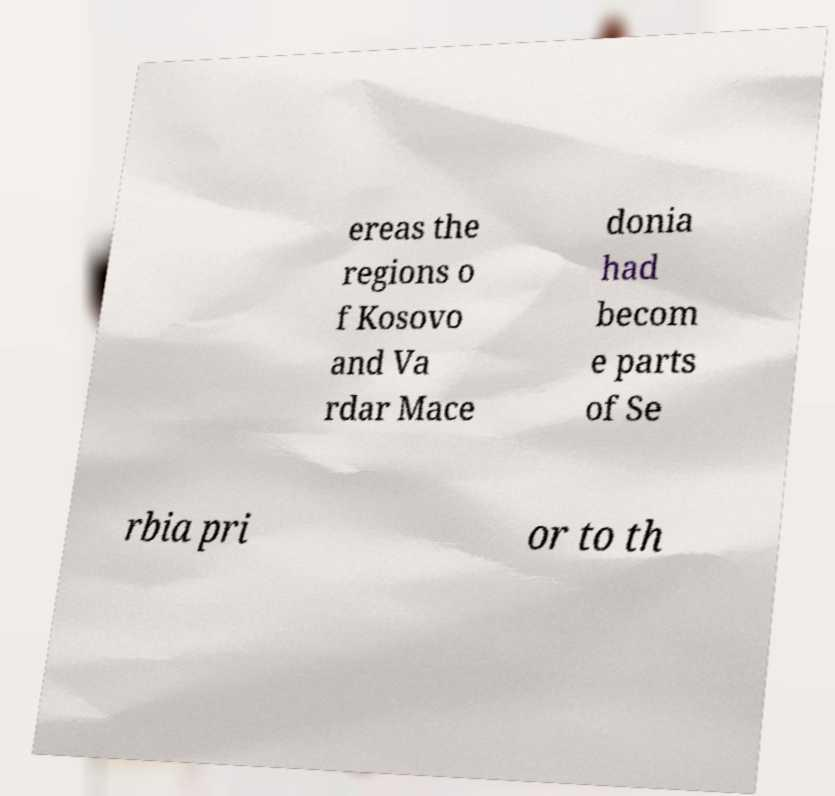Could you assist in decoding the text presented in this image and type it out clearly? ereas the regions o f Kosovo and Va rdar Mace donia had becom e parts of Se rbia pri or to th 